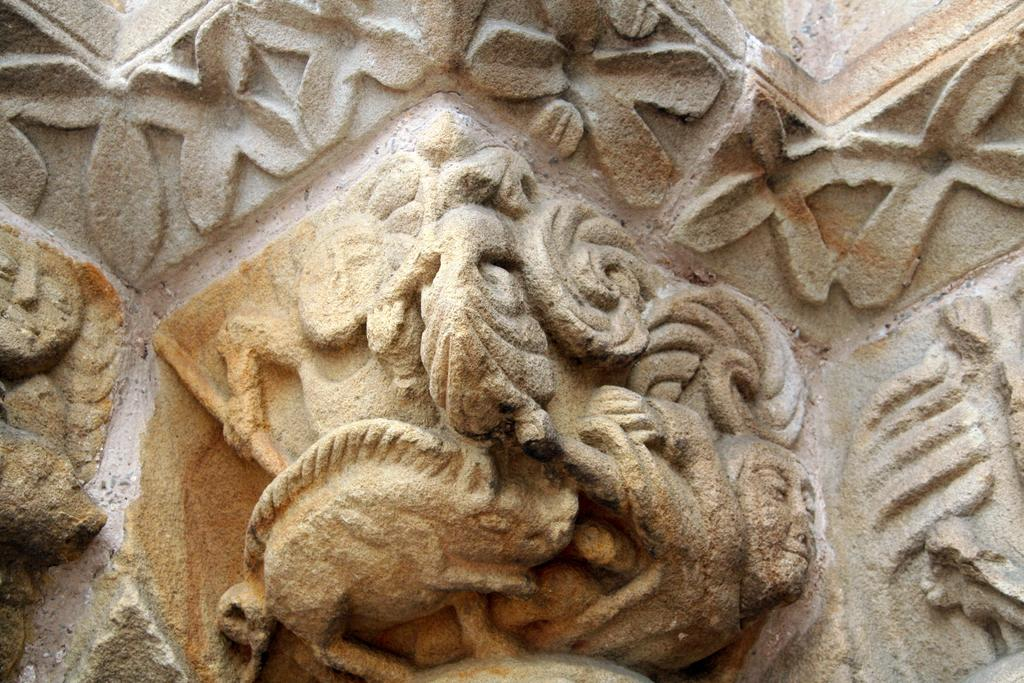What can be seen in the image in the image? There is a wall in the image. Can you describe the wall? The wall has a design. How many daughters are present in the image? There are no daughters present in the image, as it only features a wall with a design. 